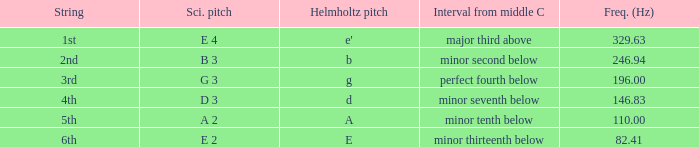What is the scientific pitch when the Helmholtz pitch is D? D 3. 